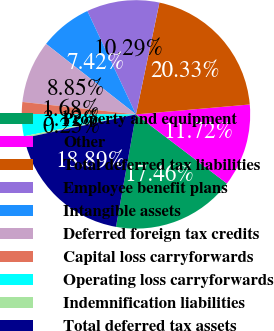Convert chart to OTSL. <chart><loc_0><loc_0><loc_500><loc_500><pie_chart><fcel>Property and equipment<fcel>Other<fcel>Total deferred tax liabilities<fcel>Employee benefit plans<fcel>Intangible assets<fcel>Deferred foreign tax credits<fcel>Capital loss carryforwards<fcel>Operating loss carryforwards<fcel>Indemnification liabilities<fcel>Total deferred tax assets<nl><fcel>17.46%<fcel>11.72%<fcel>20.33%<fcel>10.29%<fcel>7.42%<fcel>8.85%<fcel>1.68%<fcel>3.12%<fcel>0.25%<fcel>18.89%<nl></chart> 